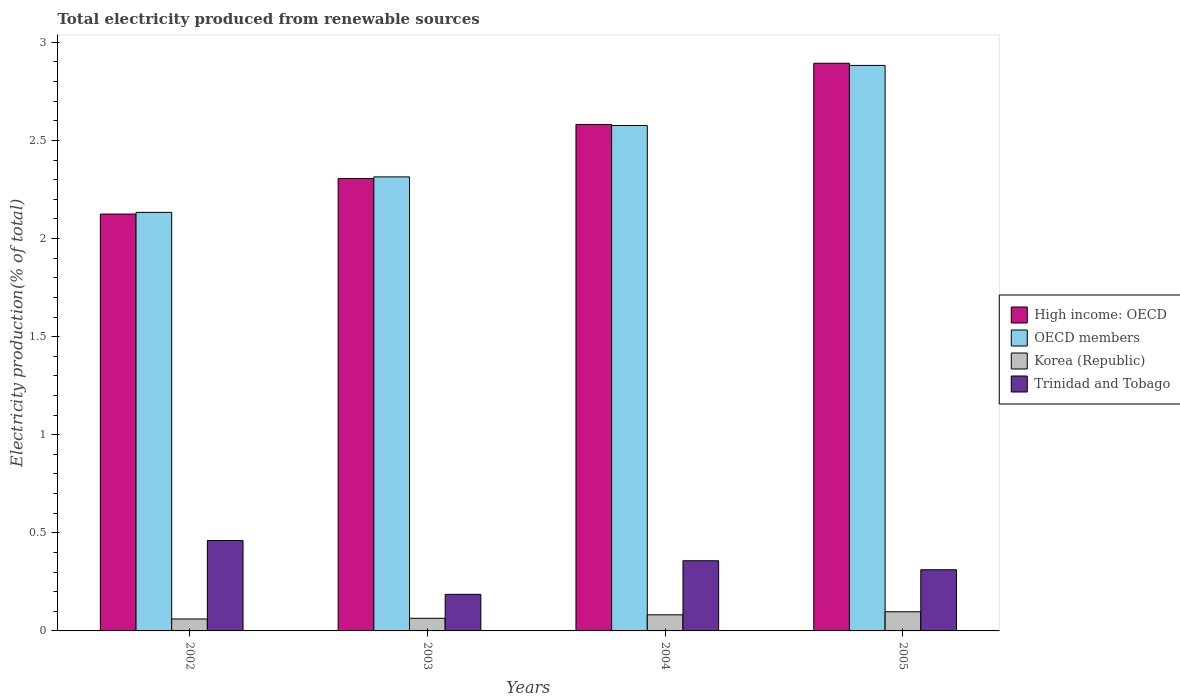How many groups of bars are there?
Your answer should be very brief. 4. Are the number of bars per tick equal to the number of legend labels?
Your answer should be compact. Yes. How many bars are there on the 4th tick from the left?
Keep it short and to the point. 4. What is the label of the 2nd group of bars from the left?
Provide a short and direct response. 2003. In how many cases, is the number of bars for a given year not equal to the number of legend labels?
Ensure brevity in your answer.  0. What is the total electricity produced in Trinidad and Tobago in 2004?
Ensure brevity in your answer.  0.36. Across all years, what is the maximum total electricity produced in High income: OECD?
Your answer should be compact. 2.89. Across all years, what is the minimum total electricity produced in Korea (Republic)?
Provide a succinct answer. 0.06. What is the total total electricity produced in OECD members in the graph?
Provide a short and direct response. 9.91. What is the difference between the total electricity produced in OECD members in 2003 and that in 2004?
Make the answer very short. -0.26. What is the difference between the total electricity produced in Trinidad and Tobago in 2003 and the total electricity produced in OECD members in 2005?
Keep it short and to the point. -2.7. What is the average total electricity produced in High income: OECD per year?
Provide a short and direct response. 2.48. In the year 2003, what is the difference between the total electricity produced in Trinidad and Tobago and total electricity produced in High income: OECD?
Offer a terse response. -2.12. What is the ratio of the total electricity produced in Trinidad and Tobago in 2003 to that in 2004?
Your answer should be compact. 0.52. What is the difference between the highest and the second highest total electricity produced in OECD members?
Ensure brevity in your answer.  0.31. What is the difference between the highest and the lowest total electricity produced in Trinidad and Tobago?
Ensure brevity in your answer.  0.27. Is it the case that in every year, the sum of the total electricity produced in Korea (Republic) and total electricity produced in High income: OECD is greater than the sum of total electricity produced in Trinidad and Tobago and total electricity produced in OECD members?
Offer a terse response. No. What does the 4th bar from the left in 2004 represents?
Offer a very short reply. Trinidad and Tobago. What does the 4th bar from the right in 2002 represents?
Your answer should be very brief. High income: OECD. Is it the case that in every year, the sum of the total electricity produced in Korea (Republic) and total electricity produced in Trinidad and Tobago is greater than the total electricity produced in High income: OECD?
Keep it short and to the point. No. How many years are there in the graph?
Make the answer very short. 4. What is the difference between two consecutive major ticks on the Y-axis?
Offer a terse response. 0.5. Are the values on the major ticks of Y-axis written in scientific E-notation?
Keep it short and to the point. No. Does the graph contain any zero values?
Offer a terse response. No. Where does the legend appear in the graph?
Provide a short and direct response. Center right. How many legend labels are there?
Keep it short and to the point. 4. What is the title of the graph?
Offer a very short reply. Total electricity produced from renewable sources. What is the Electricity production(% of total) of High income: OECD in 2002?
Offer a terse response. 2.12. What is the Electricity production(% of total) of OECD members in 2002?
Provide a short and direct response. 2.13. What is the Electricity production(% of total) in Korea (Republic) in 2002?
Offer a very short reply. 0.06. What is the Electricity production(% of total) in Trinidad and Tobago in 2002?
Offer a terse response. 0.46. What is the Electricity production(% of total) of High income: OECD in 2003?
Keep it short and to the point. 2.31. What is the Electricity production(% of total) of OECD members in 2003?
Make the answer very short. 2.31. What is the Electricity production(% of total) in Korea (Republic) in 2003?
Ensure brevity in your answer.  0.06. What is the Electricity production(% of total) in Trinidad and Tobago in 2003?
Offer a very short reply. 0.19. What is the Electricity production(% of total) of High income: OECD in 2004?
Your response must be concise. 2.58. What is the Electricity production(% of total) of OECD members in 2004?
Give a very brief answer. 2.58. What is the Electricity production(% of total) in Korea (Republic) in 2004?
Make the answer very short. 0.08. What is the Electricity production(% of total) of Trinidad and Tobago in 2004?
Provide a short and direct response. 0.36. What is the Electricity production(% of total) of High income: OECD in 2005?
Make the answer very short. 2.89. What is the Electricity production(% of total) in OECD members in 2005?
Your response must be concise. 2.88. What is the Electricity production(% of total) in Korea (Republic) in 2005?
Give a very brief answer. 0.1. What is the Electricity production(% of total) of Trinidad and Tobago in 2005?
Offer a very short reply. 0.31. Across all years, what is the maximum Electricity production(% of total) in High income: OECD?
Your response must be concise. 2.89. Across all years, what is the maximum Electricity production(% of total) of OECD members?
Offer a very short reply. 2.88. Across all years, what is the maximum Electricity production(% of total) in Korea (Republic)?
Provide a short and direct response. 0.1. Across all years, what is the maximum Electricity production(% of total) in Trinidad and Tobago?
Give a very brief answer. 0.46. Across all years, what is the minimum Electricity production(% of total) of High income: OECD?
Provide a short and direct response. 2.12. Across all years, what is the minimum Electricity production(% of total) of OECD members?
Provide a short and direct response. 2.13. Across all years, what is the minimum Electricity production(% of total) of Korea (Republic)?
Make the answer very short. 0.06. Across all years, what is the minimum Electricity production(% of total) in Trinidad and Tobago?
Give a very brief answer. 0.19. What is the total Electricity production(% of total) of High income: OECD in the graph?
Provide a short and direct response. 9.91. What is the total Electricity production(% of total) in OECD members in the graph?
Make the answer very short. 9.91. What is the total Electricity production(% of total) in Korea (Republic) in the graph?
Offer a terse response. 0.31. What is the total Electricity production(% of total) in Trinidad and Tobago in the graph?
Offer a very short reply. 1.32. What is the difference between the Electricity production(% of total) in High income: OECD in 2002 and that in 2003?
Your response must be concise. -0.18. What is the difference between the Electricity production(% of total) of OECD members in 2002 and that in 2003?
Provide a short and direct response. -0.18. What is the difference between the Electricity production(% of total) in Korea (Republic) in 2002 and that in 2003?
Your answer should be very brief. -0. What is the difference between the Electricity production(% of total) in Trinidad and Tobago in 2002 and that in 2003?
Your answer should be compact. 0.27. What is the difference between the Electricity production(% of total) of High income: OECD in 2002 and that in 2004?
Provide a succinct answer. -0.46. What is the difference between the Electricity production(% of total) in OECD members in 2002 and that in 2004?
Offer a terse response. -0.44. What is the difference between the Electricity production(% of total) of Korea (Republic) in 2002 and that in 2004?
Make the answer very short. -0.02. What is the difference between the Electricity production(% of total) in Trinidad and Tobago in 2002 and that in 2004?
Offer a terse response. 0.1. What is the difference between the Electricity production(% of total) in High income: OECD in 2002 and that in 2005?
Give a very brief answer. -0.77. What is the difference between the Electricity production(% of total) of OECD members in 2002 and that in 2005?
Provide a short and direct response. -0.75. What is the difference between the Electricity production(% of total) of Korea (Republic) in 2002 and that in 2005?
Ensure brevity in your answer.  -0.04. What is the difference between the Electricity production(% of total) of Trinidad and Tobago in 2002 and that in 2005?
Ensure brevity in your answer.  0.15. What is the difference between the Electricity production(% of total) of High income: OECD in 2003 and that in 2004?
Keep it short and to the point. -0.28. What is the difference between the Electricity production(% of total) of OECD members in 2003 and that in 2004?
Provide a short and direct response. -0.26. What is the difference between the Electricity production(% of total) of Korea (Republic) in 2003 and that in 2004?
Ensure brevity in your answer.  -0.02. What is the difference between the Electricity production(% of total) of Trinidad and Tobago in 2003 and that in 2004?
Provide a succinct answer. -0.17. What is the difference between the Electricity production(% of total) of High income: OECD in 2003 and that in 2005?
Your answer should be compact. -0.59. What is the difference between the Electricity production(% of total) in OECD members in 2003 and that in 2005?
Your response must be concise. -0.57. What is the difference between the Electricity production(% of total) of Korea (Republic) in 2003 and that in 2005?
Offer a very short reply. -0.03. What is the difference between the Electricity production(% of total) of Trinidad and Tobago in 2003 and that in 2005?
Your answer should be compact. -0.13. What is the difference between the Electricity production(% of total) in High income: OECD in 2004 and that in 2005?
Give a very brief answer. -0.31. What is the difference between the Electricity production(% of total) of OECD members in 2004 and that in 2005?
Your answer should be compact. -0.31. What is the difference between the Electricity production(% of total) of Korea (Republic) in 2004 and that in 2005?
Give a very brief answer. -0.02. What is the difference between the Electricity production(% of total) in Trinidad and Tobago in 2004 and that in 2005?
Give a very brief answer. 0.05. What is the difference between the Electricity production(% of total) of High income: OECD in 2002 and the Electricity production(% of total) of OECD members in 2003?
Your answer should be very brief. -0.19. What is the difference between the Electricity production(% of total) of High income: OECD in 2002 and the Electricity production(% of total) of Korea (Republic) in 2003?
Provide a short and direct response. 2.06. What is the difference between the Electricity production(% of total) of High income: OECD in 2002 and the Electricity production(% of total) of Trinidad and Tobago in 2003?
Provide a succinct answer. 1.94. What is the difference between the Electricity production(% of total) in OECD members in 2002 and the Electricity production(% of total) in Korea (Republic) in 2003?
Your answer should be very brief. 2.07. What is the difference between the Electricity production(% of total) in OECD members in 2002 and the Electricity production(% of total) in Trinidad and Tobago in 2003?
Your answer should be very brief. 1.95. What is the difference between the Electricity production(% of total) of Korea (Republic) in 2002 and the Electricity production(% of total) of Trinidad and Tobago in 2003?
Provide a short and direct response. -0.13. What is the difference between the Electricity production(% of total) of High income: OECD in 2002 and the Electricity production(% of total) of OECD members in 2004?
Provide a succinct answer. -0.45. What is the difference between the Electricity production(% of total) in High income: OECD in 2002 and the Electricity production(% of total) in Korea (Republic) in 2004?
Give a very brief answer. 2.04. What is the difference between the Electricity production(% of total) in High income: OECD in 2002 and the Electricity production(% of total) in Trinidad and Tobago in 2004?
Offer a terse response. 1.77. What is the difference between the Electricity production(% of total) of OECD members in 2002 and the Electricity production(% of total) of Korea (Republic) in 2004?
Your answer should be compact. 2.05. What is the difference between the Electricity production(% of total) of OECD members in 2002 and the Electricity production(% of total) of Trinidad and Tobago in 2004?
Offer a terse response. 1.78. What is the difference between the Electricity production(% of total) of Korea (Republic) in 2002 and the Electricity production(% of total) of Trinidad and Tobago in 2004?
Offer a terse response. -0.3. What is the difference between the Electricity production(% of total) of High income: OECD in 2002 and the Electricity production(% of total) of OECD members in 2005?
Offer a terse response. -0.76. What is the difference between the Electricity production(% of total) in High income: OECD in 2002 and the Electricity production(% of total) in Korea (Republic) in 2005?
Your answer should be very brief. 2.03. What is the difference between the Electricity production(% of total) of High income: OECD in 2002 and the Electricity production(% of total) of Trinidad and Tobago in 2005?
Provide a succinct answer. 1.81. What is the difference between the Electricity production(% of total) of OECD members in 2002 and the Electricity production(% of total) of Korea (Republic) in 2005?
Ensure brevity in your answer.  2.04. What is the difference between the Electricity production(% of total) in OECD members in 2002 and the Electricity production(% of total) in Trinidad and Tobago in 2005?
Your answer should be very brief. 1.82. What is the difference between the Electricity production(% of total) of Korea (Republic) in 2002 and the Electricity production(% of total) of Trinidad and Tobago in 2005?
Keep it short and to the point. -0.25. What is the difference between the Electricity production(% of total) of High income: OECD in 2003 and the Electricity production(% of total) of OECD members in 2004?
Make the answer very short. -0.27. What is the difference between the Electricity production(% of total) in High income: OECD in 2003 and the Electricity production(% of total) in Korea (Republic) in 2004?
Your answer should be compact. 2.22. What is the difference between the Electricity production(% of total) in High income: OECD in 2003 and the Electricity production(% of total) in Trinidad and Tobago in 2004?
Your answer should be compact. 1.95. What is the difference between the Electricity production(% of total) in OECD members in 2003 and the Electricity production(% of total) in Korea (Republic) in 2004?
Give a very brief answer. 2.23. What is the difference between the Electricity production(% of total) of OECD members in 2003 and the Electricity production(% of total) of Trinidad and Tobago in 2004?
Ensure brevity in your answer.  1.96. What is the difference between the Electricity production(% of total) of Korea (Republic) in 2003 and the Electricity production(% of total) of Trinidad and Tobago in 2004?
Give a very brief answer. -0.29. What is the difference between the Electricity production(% of total) in High income: OECD in 2003 and the Electricity production(% of total) in OECD members in 2005?
Keep it short and to the point. -0.58. What is the difference between the Electricity production(% of total) of High income: OECD in 2003 and the Electricity production(% of total) of Korea (Republic) in 2005?
Your answer should be compact. 2.21. What is the difference between the Electricity production(% of total) in High income: OECD in 2003 and the Electricity production(% of total) in Trinidad and Tobago in 2005?
Provide a short and direct response. 1.99. What is the difference between the Electricity production(% of total) in OECD members in 2003 and the Electricity production(% of total) in Korea (Republic) in 2005?
Your response must be concise. 2.22. What is the difference between the Electricity production(% of total) in OECD members in 2003 and the Electricity production(% of total) in Trinidad and Tobago in 2005?
Offer a terse response. 2. What is the difference between the Electricity production(% of total) of Korea (Republic) in 2003 and the Electricity production(% of total) of Trinidad and Tobago in 2005?
Keep it short and to the point. -0.25. What is the difference between the Electricity production(% of total) in High income: OECD in 2004 and the Electricity production(% of total) in OECD members in 2005?
Ensure brevity in your answer.  -0.3. What is the difference between the Electricity production(% of total) of High income: OECD in 2004 and the Electricity production(% of total) of Korea (Republic) in 2005?
Provide a succinct answer. 2.48. What is the difference between the Electricity production(% of total) of High income: OECD in 2004 and the Electricity production(% of total) of Trinidad and Tobago in 2005?
Your response must be concise. 2.27. What is the difference between the Electricity production(% of total) in OECD members in 2004 and the Electricity production(% of total) in Korea (Republic) in 2005?
Provide a short and direct response. 2.48. What is the difference between the Electricity production(% of total) in OECD members in 2004 and the Electricity production(% of total) in Trinidad and Tobago in 2005?
Ensure brevity in your answer.  2.26. What is the difference between the Electricity production(% of total) of Korea (Republic) in 2004 and the Electricity production(% of total) of Trinidad and Tobago in 2005?
Keep it short and to the point. -0.23. What is the average Electricity production(% of total) in High income: OECD per year?
Offer a terse response. 2.48. What is the average Electricity production(% of total) of OECD members per year?
Offer a terse response. 2.48. What is the average Electricity production(% of total) in Korea (Republic) per year?
Make the answer very short. 0.08. What is the average Electricity production(% of total) of Trinidad and Tobago per year?
Your answer should be very brief. 0.33. In the year 2002, what is the difference between the Electricity production(% of total) of High income: OECD and Electricity production(% of total) of OECD members?
Make the answer very short. -0.01. In the year 2002, what is the difference between the Electricity production(% of total) in High income: OECD and Electricity production(% of total) in Korea (Republic)?
Ensure brevity in your answer.  2.06. In the year 2002, what is the difference between the Electricity production(% of total) in High income: OECD and Electricity production(% of total) in Trinidad and Tobago?
Offer a terse response. 1.66. In the year 2002, what is the difference between the Electricity production(% of total) in OECD members and Electricity production(% of total) in Korea (Republic)?
Give a very brief answer. 2.07. In the year 2002, what is the difference between the Electricity production(% of total) in OECD members and Electricity production(% of total) in Trinidad and Tobago?
Your answer should be compact. 1.67. In the year 2002, what is the difference between the Electricity production(% of total) in Korea (Republic) and Electricity production(% of total) in Trinidad and Tobago?
Provide a short and direct response. -0.4. In the year 2003, what is the difference between the Electricity production(% of total) in High income: OECD and Electricity production(% of total) in OECD members?
Provide a short and direct response. -0.01. In the year 2003, what is the difference between the Electricity production(% of total) in High income: OECD and Electricity production(% of total) in Korea (Republic)?
Your response must be concise. 2.24. In the year 2003, what is the difference between the Electricity production(% of total) of High income: OECD and Electricity production(% of total) of Trinidad and Tobago?
Your response must be concise. 2.12. In the year 2003, what is the difference between the Electricity production(% of total) in OECD members and Electricity production(% of total) in Korea (Republic)?
Your response must be concise. 2.25. In the year 2003, what is the difference between the Electricity production(% of total) in OECD members and Electricity production(% of total) in Trinidad and Tobago?
Offer a terse response. 2.13. In the year 2003, what is the difference between the Electricity production(% of total) in Korea (Republic) and Electricity production(% of total) in Trinidad and Tobago?
Keep it short and to the point. -0.12. In the year 2004, what is the difference between the Electricity production(% of total) of High income: OECD and Electricity production(% of total) of OECD members?
Your answer should be very brief. 0.01. In the year 2004, what is the difference between the Electricity production(% of total) of High income: OECD and Electricity production(% of total) of Korea (Republic)?
Ensure brevity in your answer.  2.5. In the year 2004, what is the difference between the Electricity production(% of total) in High income: OECD and Electricity production(% of total) in Trinidad and Tobago?
Give a very brief answer. 2.22. In the year 2004, what is the difference between the Electricity production(% of total) of OECD members and Electricity production(% of total) of Korea (Republic)?
Your answer should be compact. 2.49. In the year 2004, what is the difference between the Electricity production(% of total) of OECD members and Electricity production(% of total) of Trinidad and Tobago?
Make the answer very short. 2.22. In the year 2004, what is the difference between the Electricity production(% of total) of Korea (Republic) and Electricity production(% of total) of Trinidad and Tobago?
Provide a succinct answer. -0.28. In the year 2005, what is the difference between the Electricity production(% of total) in High income: OECD and Electricity production(% of total) in OECD members?
Your response must be concise. 0.01. In the year 2005, what is the difference between the Electricity production(% of total) of High income: OECD and Electricity production(% of total) of Korea (Republic)?
Your answer should be compact. 2.8. In the year 2005, what is the difference between the Electricity production(% of total) in High income: OECD and Electricity production(% of total) in Trinidad and Tobago?
Your answer should be very brief. 2.58. In the year 2005, what is the difference between the Electricity production(% of total) in OECD members and Electricity production(% of total) in Korea (Republic)?
Your response must be concise. 2.78. In the year 2005, what is the difference between the Electricity production(% of total) of OECD members and Electricity production(% of total) of Trinidad and Tobago?
Offer a very short reply. 2.57. In the year 2005, what is the difference between the Electricity production(% of total) in Korea (Republic) and Electricity production(% of total) in Trinidad and Tobago?
Offer a terse response. -0.21. What is the ratio of the Electricity production(% of total) in High income: OECD in 2002 to that in 2003?
Offer a very short reply. 0.92. What is the ratio of the Electricity production(% of total) in OECD members in 2002 to that in 2003?
Keep it short and to the point. 0.92. What is the ratio of the Electricity production(% of total) of Korea (Republic) in 2002 to that in 2003?
Offer a very short reply. 0.95. What is the ratio of the Electricity production(% of total) in Trinidad and Tobago in 2002 to that in 2003?
Ensure brevity in your answer.  2.47. What is the ratio of the Electricity production(% of total) of High income: OECD in 2002 to that in 2004?
Give a very brief answer. 0.82. What is the ratio of the Electricity production(% of total) of OECD members in 2002 to that in 2004?
Keep it short and to the point. 0.83. What is the ratio of the Electricity production(% of total) of Korea (Republic) in 2002 to that in 2004?
Offer a terse response. 0.74. What is the ratio of the Electricity production(% of total) of Trinidad and Tobago in 2002 to that in 2004?
Make the answer very short. 1.29. What is the ratio of the Electricity production(% of total) of High income: OECD in 2002 to that in 2005?
Your answer should be compact. 0.73. What is the ratio of the Electricity production(% of total) of OECD members in 2002 to that in 2005?
Your response must be concise. 0.74. What is the ratio of the Electricity production(% of total) in Korea (Republic) in 2002 to that in 2005?
Ensure brevity in your answer.  0.62. What is the ratio of the Electricity production(% of total) of Trinidad and Tobago in 2002 to that in 2005?
Offer a very short reply. 1.48. What is the ratio of the Electricity production(% of total) of High income: OECD in 2003 to that in 2004?
Your response must be concise. 0.89. What is the ratio of the Electricity production(% of total) of OECD members in 2003 to that in 2004?
Keep it short and to the point. 0.9. What is the ratio of the Electricity production(% of total) of Korea (Republic) in 2003 to that in 2004?
Make the answer very short. 0.78. What is the ratio of the Electricity production(% of total) in Trinidad and Tobago in 2003 to that in 2004?
Keep it short and to the point. 0.52. What is the ratio of the Electricity production(% of total) in High income: OECD in 2003 to that in 2005?
Your response must be concise. 0.8. What is the ratio of the Electricity production(% of total) in OECD members in 2003 to that in 2005?
Provide a succinct answer. 0.8. What is the ratio of the Electricity production(% of total) of Korea (Republic) in 2003 to that in 2005?
Your answer should be compact. 0.66. What is the ratio of the Electricity production(% of total) in Trinidad and Tobago in 2003 to that in 2005?
Make the answer very short. 0.6. What is the ratio of the Electricity production(% of total) of High income: OECD in 2004 to that in 2005?
Make the answer very short. 0.89. What is the ratio of the Electricity production(% of total) in OECD members in 2004 to that in 2005?
Keep it short and to the point. 0.89. What is the ratio of the Electricity production(% of total) of Korea (Republic) in 2004 to that in 2005?
Make the answer very short. 0.84. What is the ratio of the Electricity production(% of total) in Trinidad and Tobago in 2004 to that in 2005?
Your answer should be compact. 1.15. What is the difference between the highest and the second highest Electricity production(% of total) of High income: OECD?
Provide a short and direct response. 0.31. What is the difference between the highest and the second highest Electricity production(% of total) in OECD members?
Keep it short and to the point. 0.31. What is the difference between the highest and the second highest Electricity production(% of total) of Korea (Republic)?
Provide a short and direct response. 0.02. What is the difference between the highest and the second highest Electricity production(% of total) of Trinidad and Tobago?
Provide a succinct answer. 0.1. What is the difference between the highest and the lowest Electricity production(% of total) in High income: OECD?
Give a very brief answer. 0.77. What is the difference between the highest and the lowest Electricity production(% of total) of OECD members?
Make the answer very short. 0.75. What is the difference between the highest and the lowest Electricity production(% of total) of Korea (Republic)?
Make the answer very short. 0.04. What is the difference between the highest and the lowest Electricity production(% of total) in Trinidad and Tobago?
Give a very brief answer. 0.27. 